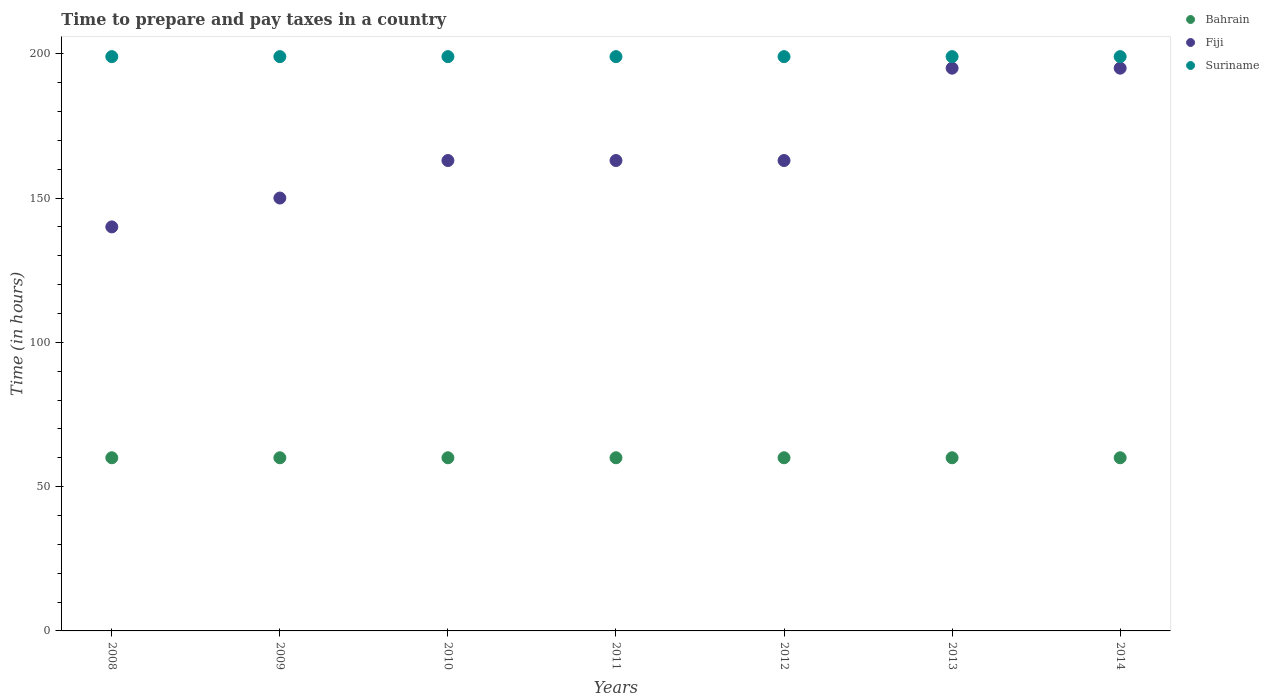What is the number of hours required to prepare and pay taxes in Fiji in 2010?
Make the answer very short. 163. Across all years, what is the minimum number of hours required to prepare and pay taxes in Suriname?
Give a very brief answer. 199. In which year was the number of hours required to prepare and pay taxes in Suriname maximum?
Offer a very short reply. 2008. What is the total number of hours required to prepare and pay taxes in Fiji in the graph?
Keep it short and to the point. 1169. What is the difference between the number of hours required to prepare and pay taxes in Suriname in 2011 and that in 2013?
Give a very brief answer. 0. What is the difference between the number of hours required to prepare and pay taxes in Fiji in 2011 and the number of hours required to prepare and pay taxes in Suriname in 2008?
Give a very brief answer. -36. What is the average number of hours required to prepare and pay taxes in Suriname per year?
Your response must be concise. 199. In the year 2009, what is the difference between the number of hours required to prepare and pay taxes in Bahrain and number of hours required to prepare and pay taxes in Fiji?
Your answer should be very brief. -90. In how many years, is the number of hours required to prepare and pay taxes in Fiji greater than 100 hours?
Ensure brevity in your answer.  7. What is the ratio of the number of hours required to prepare and pay taxes in Fiji in 2008 to that in 2010?
Your response must be concise. 0.86. Is the difference between the number of hours required to prepare and pay taxes in Bahrain in 2009 and 2013 greater than the difference between the number of hours required to prepare and pay taxes in Fiji in 2009 and 2013?
Provide a succinct answer. Yes. What is the difference between the highest and the lowest number of hours required to prepare and pay taxes in Fiji?
Offer a very short reply. 55. Is it the case that in every year, the sum of the number of hours required to prepare and pay taxes in Bahrain and number of hours required to prepare and pay taxes in Suriname  is greater than the number of hours required to prepare and pay taxes in Fiji?
Make the answer very short. Yes. Is the number of hours required to prepare and pay taxes in Suriname strictly less than the number of hours required to prepare and pay taxes in Bahrain over the years?
Your answer should be compact. No. What is the difference between two consecutive major ticks on the Y-axis?
Your answer should be very brief. 50. Are the values on the major ticks of Y-axis written in scientific E-notation?
Make the answer very short. No. Does the graph contain any zero values?
Provide a succinct answer. No. Does the graph contain grids?
Your answer should be compact. No. Where does the legend appear in the graph?
Make the answer very short. Top right. How many legend labels are there?
Give a very brief answer. 3. What is the title of the graph?
Give a very brief answer. Time to prepare and pay taxes in a country. Does "Colombia" appear as one of the legend labels in the graph?
Provide a succinct answer. No. What is the label or title of the Y-axis?
Keep it short and to the point. Time (in hours). What is the Time (in hours) of Bahrain in 2008?
Keep it short and to the point. 60. What is the Time (in hours) of Fiji in 2008?
Offer a terse response. 140. What is the Time (in hours) of Suriname in 2008?
Provide a succinct answer. 199. What is the Time (in hours) in Fiji in 2009?
Make the answer very short. 150. What is the Time (in hours) in Suriname in 2009?
Provide a succinct answer. 199. What is the Time (in hours) of Fiji in 2010?
Your answer should be compact. 163. What is the Time (in hours) in Suriname in 2010?
Keep it short and to the point. 199. What is the Time (in hours) in Bahrain in 2011?
Provide a short and direct response. 60. What is the Time (in hours) in Fiji in 2011?
Provide a short and direct response. 163. What is the Time (in hours) in Suriname in 2011?
Ensure brevity in your answer.  199. What is the Time (in hours) of Fiji in 2012?
Make the answer very short. 163. What is the Time (in hours) in Suriname in 2012?
Give a very brief answer. 199. What is the Time (in hours) of Fiji in 2013?
Make the answer very short. 195. What is the Time (in hours) of Suriname in 2013?
Your answer should be very brief. 199. What is the Time (in hours) in Fiji in 2014?
Provide a succinct answer. 195. What is the Time (in hours) of Suriname in 2014?
Offer a terse response. 199. Across all years, what is the maximum Time (in hours) in Bahrain?
Keep it short and to the point. 60. Across all years, what is the maximum Time (in hours) of Fiji?
Offer a very short reply. 195. Across all years, what is the maximum Time (in hours) of Suriname?
Your answer should be compact. 199. Across all years, what is the minimum Time (in hours) in Fiji?
Offer a very short reply. 140. Across all years, what is the minimum Time (in hours) in Suriname?
Your response must be concise. 199. What is the total Time (in hours) of Bahrain in the graph?
Offer a terse response. 420. What is the total Time (in hours) of Fiji in the graph?
Keep it short and to the point. 1169. What is the total Time (in hours) in Suriname in the graph?
Offer a very short reply. 1393. What is the difference between the Time (in hours) in Fiji in 2008 and that in 2009?
Keep it short and to the point. -10. What is the difference between the Time (in hours) in Bahrain in 2008 and that in 2010?
Your response must be concise. 0. What is the difference between the Time (in hours) in Fiji in 2008 and that in 2010?
Provide a short and direct response. -23. What is the difference between the Time (in hours) in Bahrain in 2008 and that in 2011?
Provide a succinct answer. 0. What is the difference between the Time (in hours) in Suriname in 2008 and that in 2011?
Provide a succinct answer. 0. What is the difference between the Time (in hours) of Bahrain in 2008 and that in 2013?
Offer a very short reply. 0. What is the difference between the Time (in hours) in Fiji in 2008 and that in 2013?
Provide a succinct answer. -55. What is the difference between the Time (in hours) of Fiji in 2008 and that in 2014?
Offer a terse response. -55. What is the difference between the Time (in hours) of Suriname in 2008 and that in 2014?
Your response must be concise. 0. What is the difference between the Time (in hours) of Bahrain in 2009 and that in 2010?
Provide a short and direct response. 0. What is the difference between the Time (in hours) in Bahrain in 2009 and that in 2011?
Keep it short and to the point. 0. What is the difference between the Time (in hours) in Fiji in 2009 and that in 2011?
Your answer should be compact. -13. What is the difference between the Time (in hours) of Bahrain in 2009 and that in 2012?
Give a very brief answer. 0. What is the difference between the Time (in hours) of Fiji in 2009 and that in 2012?
Your answer should be compact. -13. What is the difference between the Time (in hours) of Fiji in 2009 and that in 2013?
Provide a short and direct response. -45. What is the difference between the Time (in hours) in Suriname in 2009 and that in 2013?
Your answer should be very brief. 0. What is the difference between the Time (in hours) in Bahrain in 2009 and that in 2014?
Make the answer very short. 0. What is the difference between the Time (in hours) of Fiji in 2009 and that in 2014?
Your response must be concise. -45. What is the difference between the Time (in hours) of Suriname in 2009 and that in 2014?
Provide a succinct answer. 0. What is the difference between the Time (in hours) in Bahrain in 2010 and that in 2011?
Offer a very short reply. 0. What is the difference between the Time (in hours) in Suriname in 2010 and that in 2011?
Provide a short and direct response. 0. What is the difference between the Time (in hours) of Bahrain in 2010 and that in 2012?
Offer a very short reply. 0. What is the difference between the Time (in hours) in Fiji in 2010 and that in 2013?
Give a very brief answer. -32. What is the difference between the Time (in hours) of Suriname in 2010 and that in 2013?
Provide a succinct answer. 0. What is the difference between the Time (in hours) of Bahrain in 2010 and that in 2014?
Provide a short and direct response. 0. What is the difference between the Time (in hours) of Fiji in 2010 and that in 2014?
Ensure brevity in your answer.  -32. What is the difference between the Time (in hours) in Suriname in 2010 and that in 2014?
Your answer should be compact. 0. What is the difference between the Time (in hours) in Fiji in 2011 and that in 2013?
Keep it short and to the point. -32. What is the difference between the Time (in hours) of Fiji in 2011 and that in 2014?
Offer a terse response. -32. What is the difference between the Time (in hours) in Fiji in 2012 and that in 2013?
Ensure brevity in your answer.  -32. What is the difference between the Time (in hours) in Suriname in 2012 and that in 2013?
Keep it short and to the point. 0. What is the difference between the Time (in hours) of Fiji in 2012 and that in 2014?
Provide a succinct answer. -32. What is the difference between the Time (in hours) in Bahrain in 2013 and that in 2014?
Your answer should be very brief. 0. What is the difference between the Time (in hours) of Suriname in 2013 and that in 2014?
Offer a very short reply. 0. What is the difference between the Time (in hours) of Bahrain in 2008 and the Time (in hours) of Fiji in 2009?
Ensure brevity in your answer.  -90. What is the difference between the Time (in hours) of Bahrain in 2008 and the Time (in hours) of Suriname in 2009?
Ensure brevity in your answer.  -139. What is the difference between the Time (in hours) of Fiji in 2008 and the Time (in hours) of Suriname in 2009?
Keep it short and to the point. -59. What is the difference between the Time (in hours) of Bahrain in 2008 and the Time (in hours) of Fiji in 2010?
Give a very brief answer. -103. What is the difference between the Time (in hours) of Bahrain in 2008 and the Time (in hours) of Suriname in 2010?
Offer a terse response. -139. What is the difference between the Time (in hours) of Fiji in 2008 and the Time (in hours) of Suriname in 2010?
Your response must be concise. -59. What is the difference between the Time (in hours) of Bahrain in 2008 and the Time (in hours) of Fiji in 2011?
Your answer should be very brief. -103. What is the difference between the Time (in hours) in Bahrain in 2008 and the Time (in hours) in Suriname in 2011?
Keep it short and to the point. -139. What is the difference between the Time (in hours) in Fiji in 2008 and the Time (in hours) in Suriname in 2011?
Make the answer very short. -59. What is the difference between the Time (in hours) of Bahrain in 2008 and the Time (in hours) of Fiji in 2012?
Offer a terse response. -103. What is the difference between the Time (in hours) of Bahrain in 2008 and the Time (in hours) of Suriname in 2012?
Offer a very short reply. -139. What is the difference between the Time (in hours) of Fiji in 2008 and the Time (in hours) of Suriname in 2012?
Provide a short and direct response. -59. What is the difference between the Time (in hours) of Bahrain in 2008 and the Time (in hours) of Fiji in 2013?
Offer a very short reply. -135. What is the difference between the Time (in hours) of Bahrain in 2008 and the Time (in hours) of Suriname in 2013?
Make the answer very short. -139. What is the difference between the Time (in hours) of Fiji in 2008 and the Time (in hours) of Suriname in 2013?
Make the answer very short. -59. What is the difference between the Time (in hours) in Bahrain in 2008 and the Time (in hours) in Fiji in 2014?
Your answer should be very brief. -135. What is the difference between the Time (in hours) of Bahrain in 2008 and the Time (in hours) of Suriname in 2014?
Your answer should be compact. -139. What is the difference between the Time (in hours) of Fiji in 2008 and the Time (in hours) of Suriname in 2014?
Your response must be concise. -59. What is the difference between the Time (in hours) in Bahrain in 2009 and the Time (in hours) in Fiji in 2010?
Provide a short and direct response. -103. What is the difference between the Time (in hours) of Bahrain in 2009 and the Time (in hours) of Suriname in 2010?
Keep it short and to the point. -139. What is the difference between the Time (in hours) in Fiji in 2009 and the Time (in hours) in Suriname in 2010?
Your answer should be very brief. -49. What is the difference between the Time (in hours) in Bahrain in 2009 and the Time (in hours) in Fiji in 2011?
Your answer should be compact. -103. What is the difference between the Time (in hours) in Bahrain in 2009 and the Time (in hours) in Suriname in 2011?
Give a very brief answer. -139. What is the difference between the Time (in hours) of Fiji in 2009 and the Time (in hours) of Suriname in 2011?
Offer a very short reply. -49. What is the difference between the Time (in hours) of Bahrain in 2009 and the Time (in hours) of Fiji in 2012?
Offer a terse response. -103. What is the difference between the Time (in hours) of Bahrain in 2009 and the Time (in hours) of Suriname in 2012?
Make the answer very short. -139. What is the difference between the Time (in hours) of Fiji in 2009 and the Time (in hours) of Suriname in 2012?
Make the answer very short. -49. What is the difference between the Time (in hours) in Bahrain in 2009 and the Time (in hours) in Fiji in 2013?
Make the answer very short. -135. What is the difference between the Time (in hours) in Bahrain in 2009 and the Time (in hours) in Suriname in 2013?
Provide a succinct answer. -139. What is the difference between the Time (in hours) in Fiji in 2009 and the Time (in hours) in Suriname in 2013?
Provide a short and direct response. -49. What is the difference between the Time (in hours) of Bahrain in 2009 and the Time (in hours) of Fiji in 2014?
Your answer should be very brief. -135. What is the difference between the Time (in hours) in Bahrain in 2009 and the Time (in hours) in Suriname in 2014?
Keep it short and to the point. -139. What is the difference between the Time (in hours) of Fiji in 2009 and the Time (in hours) of Suriname in 2014?
Offer a terse response. -49. What is the difference between the Time (in hours) of Bahrain in 2010 and the Time (in hours) of Fiji in 2011?
Your response must be concise. -103. What is the difference between the Time (in hours) of Bahrain in 2010 and the Time (in hours) of Suriname in 2011?
Give a very brief answer. -139. What is the difference between the Time (in hours) in Fiji in 2010 and the Time (in hours) in Suriname in 2011?
Give a very brief answer. -36. What is the difference between the Time (in hours) of Bahrain in 2010 and the Time (in hours) of Fiji in 2012?
Ensure brevity in your answer.  -103. What is the difference between the Time (in hours) of Bahrain in 2010 and the Time (in hours) of Suriname in 2012?
Ensure brevity in your answer.  -139. What is the difference between the Time (in hours) of Fiji in 2010 and the Time (in hours) of Suriname in 2012?
Provide a succinct answer. -36. What is the difference between the Time (in hours) of Bahrain in 2010 and the Time (in hours) of Fiji in 2013?
Offer a terse response. -135. What is the difference between the Time (in hours) in Bahrain in 2010 and the Time (in hours) in Suriname in 2013?
Give a very brief answer. -139. What is the difference between the Time (in hours) in Fiji in 2010 and the Time (in hours) in Suriname in 2013?
Keep it short and to the point. -36. What is the difference between the Time (in hours) of Bahrain in 2010 and the Time (in hours) of Fiji in 2014?
Your answer should be very brief. -135. What is the difference between the Time (in hours) of Bahrain in 2010 and the Time (in hours) of Suriname in 2014?
Offer a very short reply. -139. What is the difference between the Time (in hours) in Fiji in 2010 and the Time (in hours) in Suriname in 2014?
Provide a succinct answer. -36. What is the difference between the Time (in hours) in Bahrain in 2011 and the Time (in hours) in Fiji in 2012?
Give a very brief answer. -103. What is the difference between the Time (in hours) of Bahrain in 2011 and the Time (in hours) of Suriname in 2012?
Ensure brevity in your answer.  -139. What is the difference between the Time (in hours) of Fiji in 2011 and the Time (in hours) of Suriname in 2012?
Give a very brief answer. -36. What is the difference between the Time (in hours) of Bahrain in 2011 and the Time (in hours) of Fiji in 2013?
Your response must be concise. -135. What is the difference between the Time (in hours) of Bahrain in 2011 and the Time (in hours) of Suriname in 2013?
Provide a short and direct response. -139. What is the difference between the Time (in hours) of Fiji in 2011 and the Time (in hours) of Suriname in 2013?
Give a very brief answer. -36. What is the difference between the Time (in hours) in Bahrain in 2011 and the Time (in hours) in Fiji in 2014?
Give a very brief answer. -135. What is the difference between the Time (in hours) of Bahrain in 2011 and the Time (in hours) of Suriname in 2014?
Keep it short and to the point. -139. What is the difference between the Time (in hours) of Fiji in 2011 and the Time (in hours) of Suriname in 2014?
Your response must be concise. -36. What is the difference between the Time (in hours) of Bahrain in 2012 and the Time (in hours) of Fiji in 2013?
Provide a succinct answer. -135. What is the difference between the Time (in hours) in Bahrain in 2012 and the Time (in hours) in Suriname in 2013?
Provide a succinct answer. -139. What is the difference between the Time (in hours) in Fiji in 2012 and the Time (in hours) in Suriname in 2013?
Offer a terse response. -36. What is the difference between the Time (in hours) of Bahrain in 2012 and the Time (in hours) of Fiji in 2014?
Your answer should be very brief. -135. What is the difference between the Time (in hours) in Bahrain in 2012 and the Time (in hours) in Suriname in 2014?
Make the answer very short. -139. What is the difference between the Time (in hours) in Fiji in 2012 and the Time (in hours) in Suriname in 2014?
Your answer should be compact. -36. What is the difference between the Time (in hours) of Bahrain in 2013 and the Time (in hours) of Fiji in 2014?
Make the answer very short. -135. What is the difference between the Time (in hours) of Bahrain in 2013 and the Time (in hours) of Suriname in 2014?
Keep it short and to the point. -139. What is the difference between the Time (in hours) of Fiji in 2013 and the Time (in hours) of Suriname in 2014?
Keep it short and to the point. -4. What is the average Time (in hours) of Bahrain per year?
Provide a succinct answer. 60. What is the average Time (in hours) in Fiji per year?
Offer a very short reply. 167. What is the average Time (in hours) in Suriname per year?
Provide a succinct answer. 199. In the year 2008, what is the difference between the Time (in hours) of Bahrain and Time (in hours) of Fiji?
Your answer should be compact. -80. In the year 2008, what is the difference between the Time (in hours) in Bahrain and Time (in hours) in Suriname?
Offer a very short reply. -139. In the year 2008, what is the difference between the Time (in hours) in Fiji and Time (in hours) in Suriname?
Your answer should be compact. -59. In the year 2009, what is the difference between the Time (in hours) of Bahrain and Time (in hours) of Fiji?
Your answer should be very brief. -90. In the year 2009, what is the difference between the Time (in hours) in Bahrain and Time (in hours) in Suriname?
Provide a succinct answer. -139. In the year 2009, what is the difference between the Time (in hours) of Fiji and Time (in hours) of Suriname?
Your answer should be compact. -49. In the year 2010, what is the difference between the Time (in hours) in Bahrain and Time (in hours) in Fiji?
Keep it short and to the point. -103. In the year 2010, what is the difference between the Time (in hours) of Bahrain and Time (in hours) of Suriname?
Provide a succinct answer. -139. In the year 2010, what is the difference between the Time (in hours) in Fiji and Time (in hours) in Suriname?
Your answer should be very brief. -36. In the year 2011, what is the difference between the Time (in hours) in Bahrain and Time (in hours) in Fiji?
Your answer should be very brief. -103. In the year 2011, what is the difference between the Time (in hours) in Bahrain and Time (in hours) in Suriname?
Your answer should be very brief. -139. In the year 2011, what is the difference between the Time (in hours) of Fiji and Time (in hours) of Suriname?
Make the answer very short. -36. In the year 2012, what is the difference between the Time (in hours) in Bahrain and Time (in hours) in Fiji?
Keep it short and to the point. -103. In the year 2012, what is the difference between the Time (in hours) in Bahrain and Time (in hours) in Suriname?
Your answer should be compact. -139. In the year 2012, what is the difference between the Time (in hours) in Fiji and Time (in hours) in Suriname?
Ensure brevity in your answer.  -36. In the year 2013, what is the difference between the Time (in hours) in Bahrain and Time (in hours) in Fiji?
Provide a short and direct response. -135. In the year 2013, what is the difference between the Time (in hours) of Bahrain and Time (in hours) of Suriname?
Provide a succinct answer. -139. In the year 2013, what is the difference between the Time (in hours) of Fiji and Time (in hours) of Suriname?
Offer a very short reply. -4. In the year 2014, what is the difference between the Time (in hours) in Bahrain and Time (in hours) in Fiji?
Your response must be concise. -135. In the year 2014, what is the difference between the Time (in hours) in Bahrain and Time (in hours) in Suriname?
Provide a succinct answer. -139. In the year 2014, what is the difference between the Time (in hours) of Fiji and Time (in hours) of Suriname?
Offer a terse response. -4. What is the ratio of the Time (in hours) in Suriname in 2008 to that in 2009?
Make the answer very short. 1. What is the ratio of the Time (in hours) in Fiji in 2008 to that in 2010?
Give a very brief answer. 0.86. What is the ratio of the Time (in hours) in Suriname in 2008 to that in 2010?
Give a very brief answer. 1. What is the ratio of the Time (in hours) in Bahrain in 2008 to that in 2011?
Offer a very short reply. 1. What is the ratio of the Time (in hours) in Fiji in 2008 to that in 2011?
Make the answer very short. 0.86. What is the ratio of the Time (in hours) of Fiji in 2008 to that in 2012?
Provide a succinct answer. 0.86. What is the ratio of the Time (in hours) of Bahrain in 2008 to that in 2013?
Your response must be concise. 1. What is the ratio of the Time (in hours) in Fiji in 2008 to that in 2013?
Provide a succinct answer. 0.72. What is the ratio of the Time (in hours) in Suriname in 2008 to that in 2013?
Offer a terse response. 1. What is the ratio of the Time (in hours) in Bahrain in 2008 to that in 2014?
Provide a short and direct response. 1. What is the ratio of the Time (in hours) in Fiji in 2008 to that in 2014?
Make the answer very short. 0.72. What is the ratio of the Time (in hours) in Bahrain in 2009 to that in 2010?
Keep it short and to the point. 1. What is the ratio of the Time (in hours) of Fiji in 2009 to that in 2010?
Your answer should be compact. 0.92. What is the ratio of the Time (in hours) in Suriname in 2009 to that in 2010?
Your response must be concise. 1. What is the ratio of the Time (in hours) of Fiji in 2009 to that in 2011?
Offer a terse response. 0.92. What is the ratio of the Time (in hours) in Suriname in 2009 to that in 2011?
Make the answer very short. 1. What is the ratio of the Time (in hours) in Bahrain in 2009 to that in 2012?
Provide a succinct answer. 1. What is the ratio of the Time (in hours) of Fiji in 2009 to that in 2012?
Ensure brevity in your answer.  0.92. What is the ratio of the Time (in hours) of Suriname in 2009 to that in 2012?
Offer a terse response. 1. What is the ratio of the Time (in hours) in Fiji in 2009 to that in 2013?
Your answer should be very brief. 0.77. What is the ratio of the Time (in hours) in Suriname in 2009 to that in 2013?
Your response must be concise. 1. What is the ratio of the Time (in hours) in Fiji in 2009 to that in 2014?
Ensure brevity in your answer.  0.77. What is the ratio of the Time (in hours) in Suriname in 2009 to that in 2014?
Your answer should be compact. 1. What is the ratio of the Time (in hours) of Suriname in 2010 to that in 2011?
Make the answer very short. 1. What is the ratio of the Time (in hours) of Fiji in 2010 to that in 2012?
Make the answer very short. 1. What is the ratio of the Time (in hours) of Bahrain in 2010 to that in 2013?
Ensure brevity in your answer.  1. What is the ratio of the Time (in hours) of Fiji in 2010 to that in 2013?
Your answer should be compact. 0.84. What is the ratio of the Time (in hours) in Fiji in 2010 to that in 2014?
Offer a very short reply. 0.84. What is the ratio of the Time (in hours) in Bahrain in 2011 to that in 2012?
Offer a terse response. 1. What is the ratio of the Time (in hours) in Fiji in 2011 to that in 2012?
Provide a short and direct response. 1. What is the ratio of the Time (in hours) in Bahrain in 2011 to that in 2013?
Keep it short and to the point. 1. What is the ratio of the Time (in hours) of Fiji in 2011 to that in 2013?
Provide a short and direct response. 0.84. What is the ratio of the Time (in hours) in Suriname in 2011 to that in 2013?
Your answer should be compact. 1. What is the ratio of the Time (in hours) in Fiji in 2011 to that in 2014?
Your answer should be very brief. 0.84. What is the ratio of the Time (in hours) in Fiji in 2012 to that in 2013?
Offer a terse response. 0.84. What is the ratio of the Time (in hours) in Bahrain in 2012 to that in 2014?
Provide a succinct answer. 1. What is the ratio of the Time (in hours) of Fiji in 2012 to that in 2014?
Provide a succinct answer. 0.84. What is the ratio of the Time (in hours) in Suriname in 2012 to that in 2014?
Keep it short and to the point. 1. What is the ratio of the Time (in hours) in Bahrain in 2013 to that in 2014?
Offer a terse response. 1. What is the ratio of the Time (in hours) in Fiji in 2013 to that in 2014?
Provide a succinct answer. 1. What is the difference between the highest and the second highest Time (in hours) in Fiji?
Your answer should be compact. 0. What is the difference between the highest and the lowest Time (in hours) of Bahrain?
Offer a terse response. 0. 